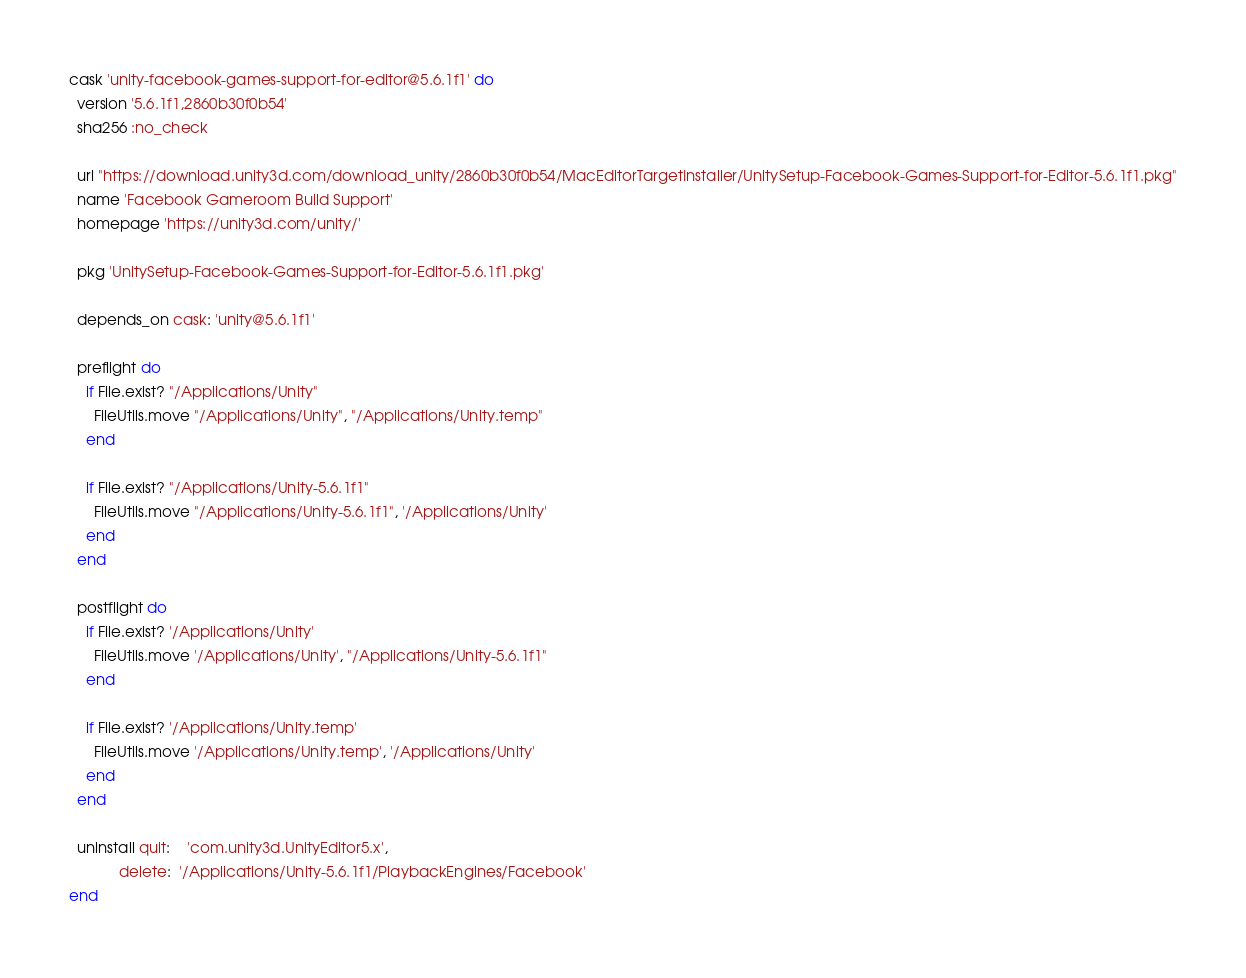Convert code to text. <code><loc_0><loc_0><loc_500><loc_500><_Ruby_>cask 'unity-facebook-games-support-for-editor@5.6.1f1' do
  version '5.6.1f1,2860b30f0b54'
  sha256 :no_check

  url "https://download.unity3d.com/download_unity/2860b30f0b54/MacEditorTargetInstaller/UnitySetup-Facebook-Games-Support-for-Editor-5.6.1f1.pkg"
  name 'Facebook Gameroom Build Support'
  homepage 'https://unity3d.com/unity/'

  pkg 'UnitySetup-Facebook-Games-Support-for-Editor-5.6.1f1.pkg'

  depends_on cask: 'unity@5.6.1f1'

  preflight do
    if File.exist? "/Applications/Unity"
      FileUtils.move "/Applications/Unity", "/Applications/Unity.temp"
    end

    if File.exist? "/Applications/Unity-5.6.1f1"
      FileUtils.move "/Applications/Unity-5.6.1f1", '/Applications/Unity'
    end
  end

  postflight do
    if File.exist? '/Applications/Unity'
      FileUtils.move '/Applications/Unity', "/Applications/Unity-5.6.1f1"
    end

    if File.exist? '/Applications/Unity.temp'
      FileUtils.move '/Applications/Unity.temp', '/Applications/Unity'
    end
  end

  uninstall quit:    'com.unity3d.UnityEditor5.x',
            delete:  '/Applications/Unity-5.6.1f1/PlaybackEngines/Facebook'
end
</code> 